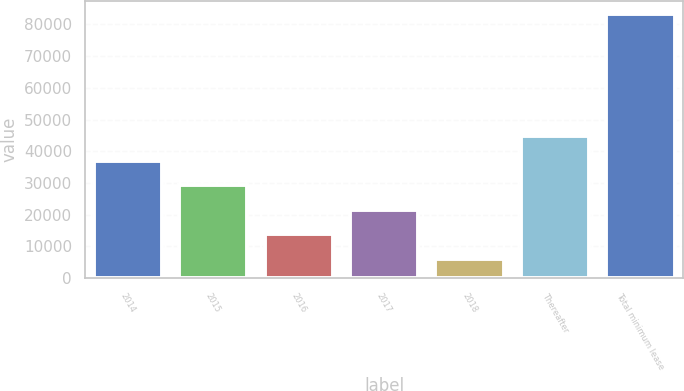Convert chart to OTSL. <chart><loc_0><loc_0><loc_500><loc_500><bar_chart><fcel>2014<fcel>2015<fcel>2016<fcel>2017<fcel>2018<fcel>Thereafter<fcel>Total minimum lease<nl><fcel>37013<fcel>29286<fcel>13832<fcel>21559<fcel>6105<fcel>44740<fcel>83375<nl></chart> 